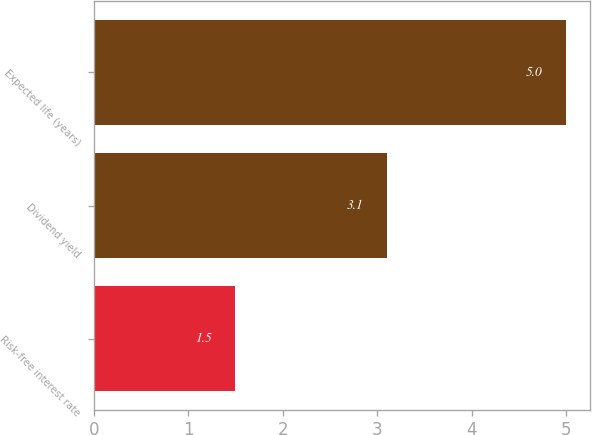Convert chart. <chart><loc_0><loc_0><loc_500><loc_500><bar_chart><fcel>Risk-free interest rate<fcel>Dividend yield<fcel>Expected life (years)<nl><fcel>1.5<fcel>3.1<fcel>5<nl></chart> 